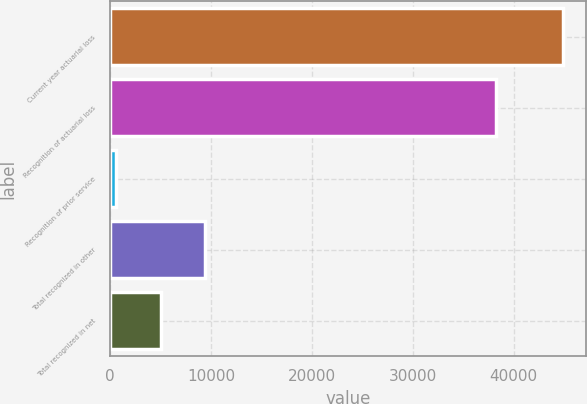Convert chart to OTSL. <chart><loc_0><loc_0><loc_500><loc_500><bar_chart><fcel>Current year actuarial loss<fcel>Recognition of actuarial loss<fcel>Recognition of prior service<fcel>Total recognized in other<fcel>Total recognized in net<nl><fcel>44930<fcel>38197<fcel>565<fcel>9438<fcel>5001.5<nl></chart> 